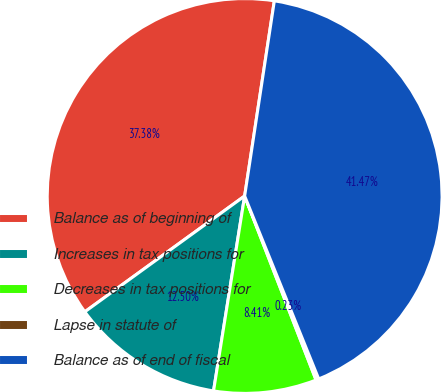Convert chart. <chart><loc_0><loc_0><loc_500><loc_500><pie_chart><fcel>Balance as of beginning of<fcel>Increases in tax positions for<fcel>Decreases in tax positions for<fcel>Lapse in statute of<fcel>Balance as of end of fiscal<nl><fcel>37.38%<fcel>12.5%<fcel>8.41%<fcel>0.23%<fcel>41.47%<nl></chart> 